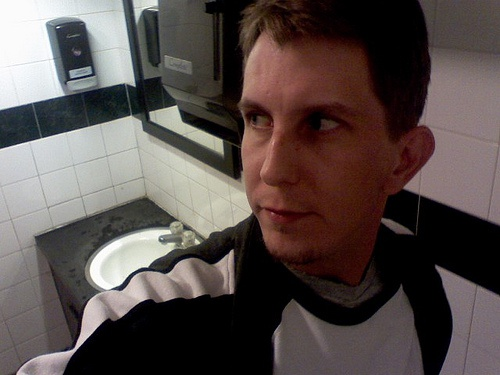Describe the objects in this image and their specific colors. I can see people in white, black, maroon, gray, and brown tones and sink in white, ivory, darkgray, gray, and black tones in this image. 